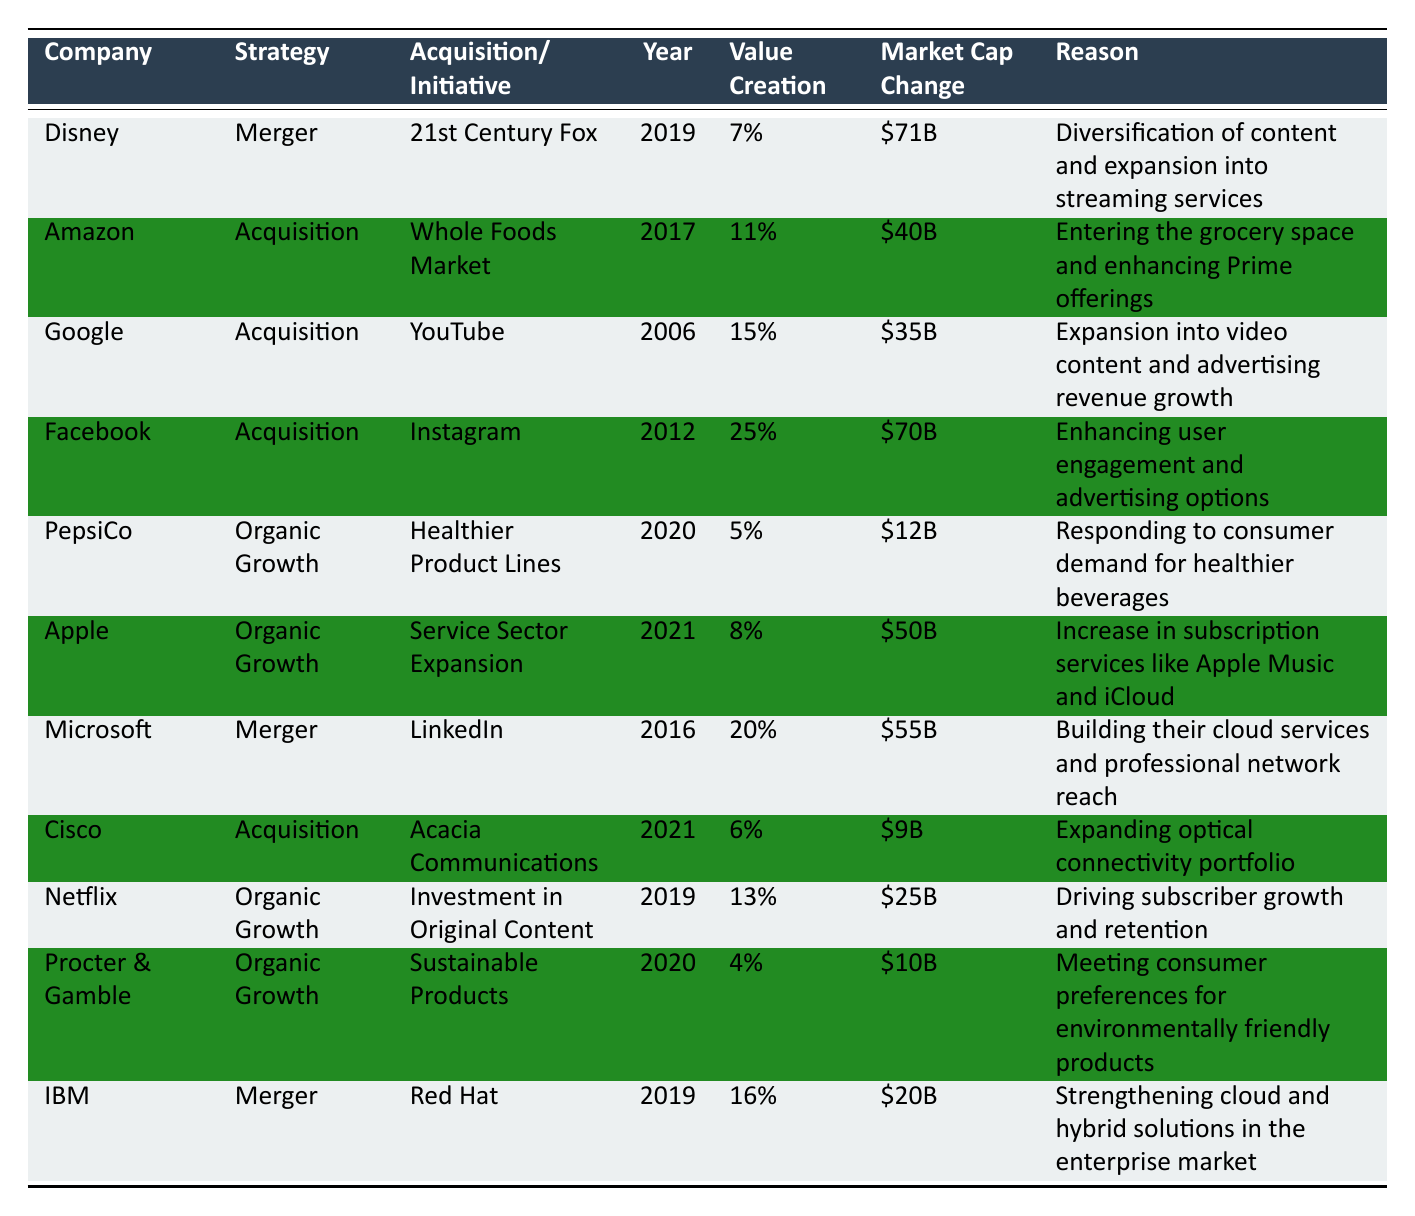What was the acquisition made by Facebook? According to the table, Facebook acquired Instagram.
Answer: Instagram Which company had the highest shareholder value creation from an acquisition strategy? The table shows that Facebook achieved the highest shareholder value creation at 25% from its acquisition of Instagram.
Answer: Facebook with 25% What is the market cap change for Cisco following its acquisition? The table indicates that Cisco's market cap change after the acquisition of Acacia Communications was $9 billion.
Answer: $9 billion Calculate the average shareholder value creation for organic growth strategies. The organic growth strategies listed are PepsiCo (5%), Apple (8%), Netflix (13%), and Procter & Gamble (4%). Their sum is 5 + 8 + 13 + 4 = 30, and there are 4 entries, so the average is 30/4 = 7.5%.
Answer: 7.5% Did any merger strategy result in a lower shareholder value creation than the highest organic growth strategy? The highest organic growth strategy is 13% by Netflix, while the merger strategies are Disney (7%), Microsoft (20%), and IBM (16%). Since Disney at 7% is lower than 13%, the answer is yes.
Answer: Yes What was the main reason for Disney's merger with 21st Century Fox? The reason stated in the table is diversification of content and expansion into streaming services.
Answer: Diversification of content and expansion into streaming services Compare the market cap change from the acquisition of Whole Foods Market to the merger with LinkedIn. Market cap change for Whole Foods Market acquisition by Amazon is $40 billion, and for LinkedIn merger by Microsoft it is $55 billion. $55B - $40B = $15B. Therefore, LinkedIn's merger had a $15 billion greater market cap change.
Answer: $15 billion List the companies that followed organic growth strategies. According to the table, the companies using organic growth strategies are PepsiCo, Apple, Netflix, and Procter & Gamble.
Answer: PepsiCo, Apple, Netflix, Procter & Gamble What is the market cap change for the 21st Century Fox merger? The table indicates that the market cap change for the Disney merger with 21st Century Fox was $71 billion.
Answer: $71 billion Which acquisition strategy had the lowest shareholder value creation? Reviewing the data, PepsiCo's organic growth strategy produced the lowest shareholder value creation at 5%.
Answer: 5% 